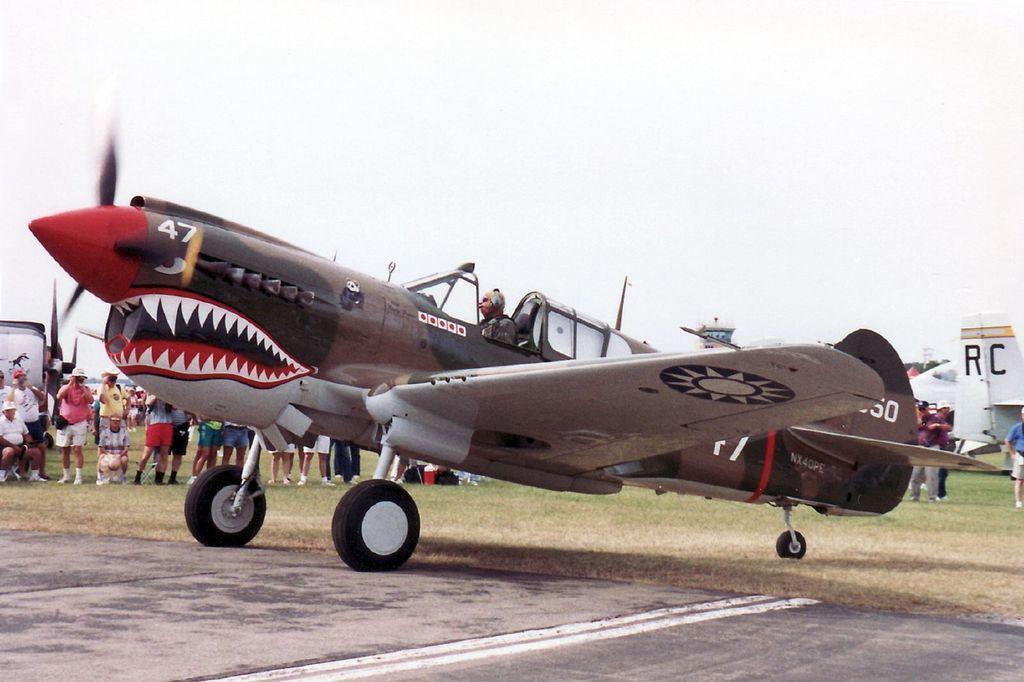Please provide a concise description of this image. In this picture we can observe an airplane on the ground. There is a runway. We can observe some people standing on the ground. In the background there is a sky. 